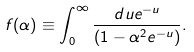Convert formula to latex. <formula><loc_0><loc_0><loc_500><loc_500>f ( \alpha ) \equiv \int _ { 0 } ^ { \infty } \frac { d u e ^ { - u } } { ( 1 - \alpha ^ { 2 } e ^ { - u } ) } .</formula> 